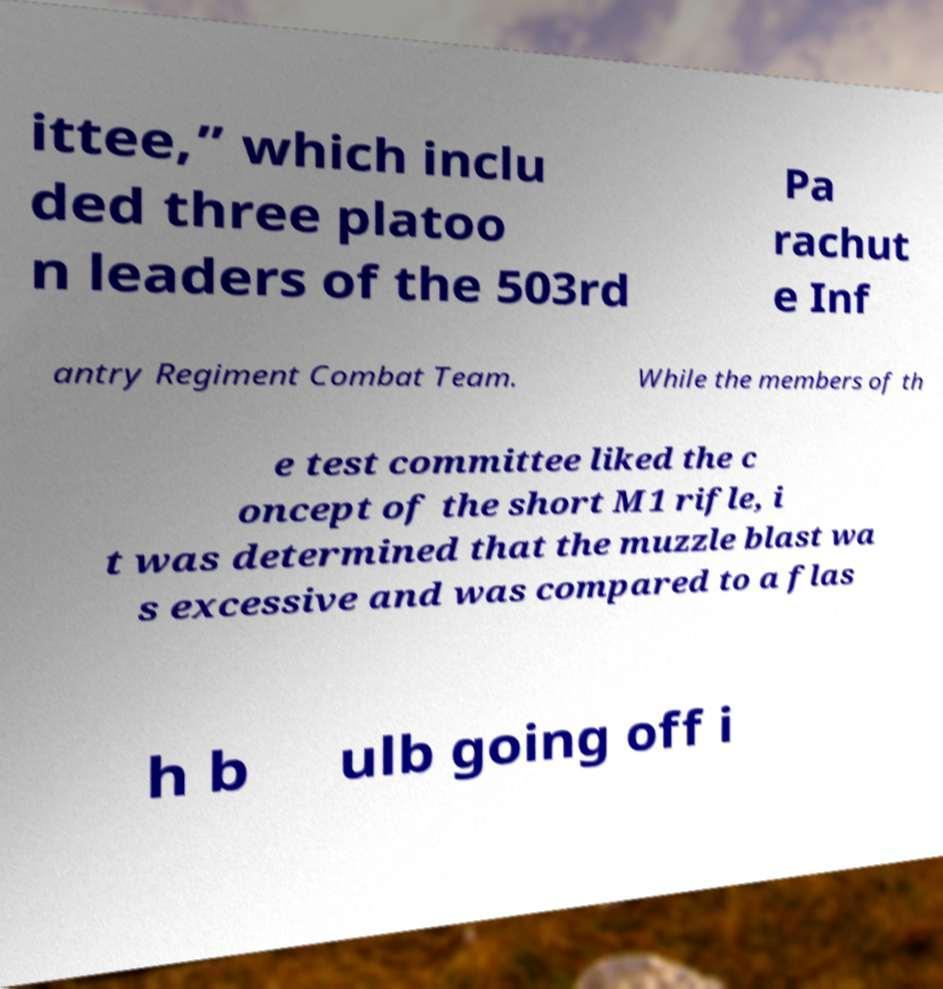Please read and relay the text visible in this image. What does it say? ittee,” which inclu ded three platoo n leaders of the 503rd Pa rachut e Inf antry Regiment Combat Team. While the members of th e test committee liked the c oncept of the short M1 rifle, i t was determined that the muzzle blast wa s excessive and was compared to a flas h b ulb going off i 